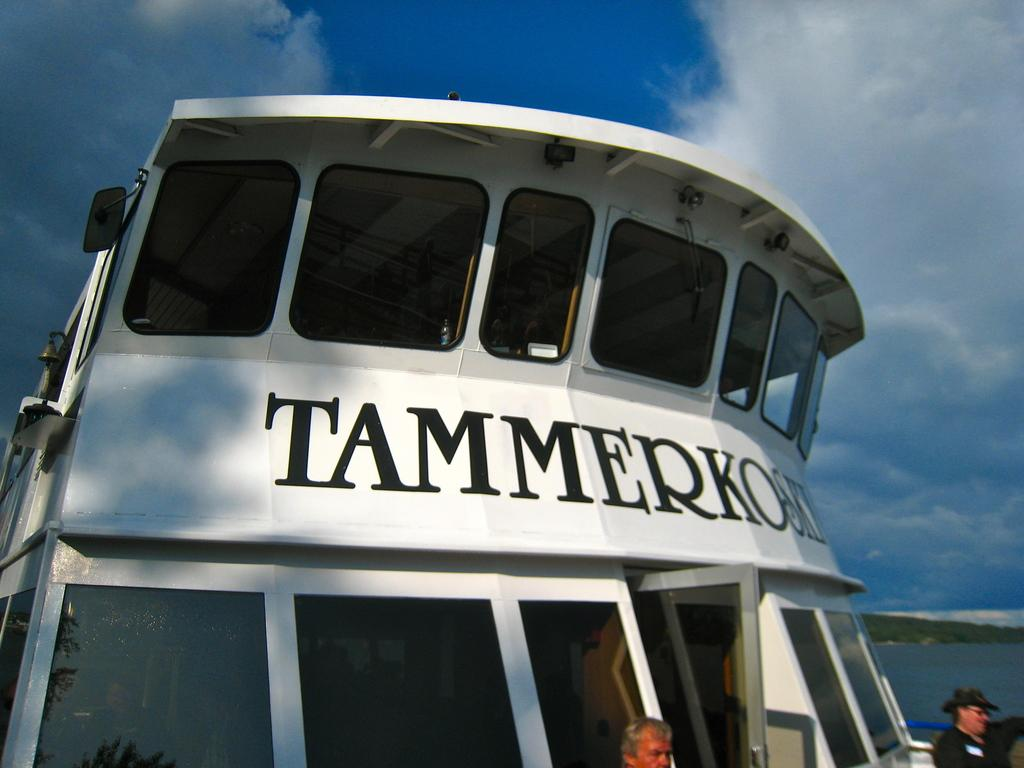How many people are in the image? There are two persons in the image. What is the main subject in the image? The main subject in the image is a ship. What is the setting of the image? The image is set on water, with the sky visible in the background. What can be seen in the sky? Clouds are present in the sky. What type of humor can be seen in the boy's expression in the image? There is no boy present in the image, and therefore no expression to analyze for humor. 